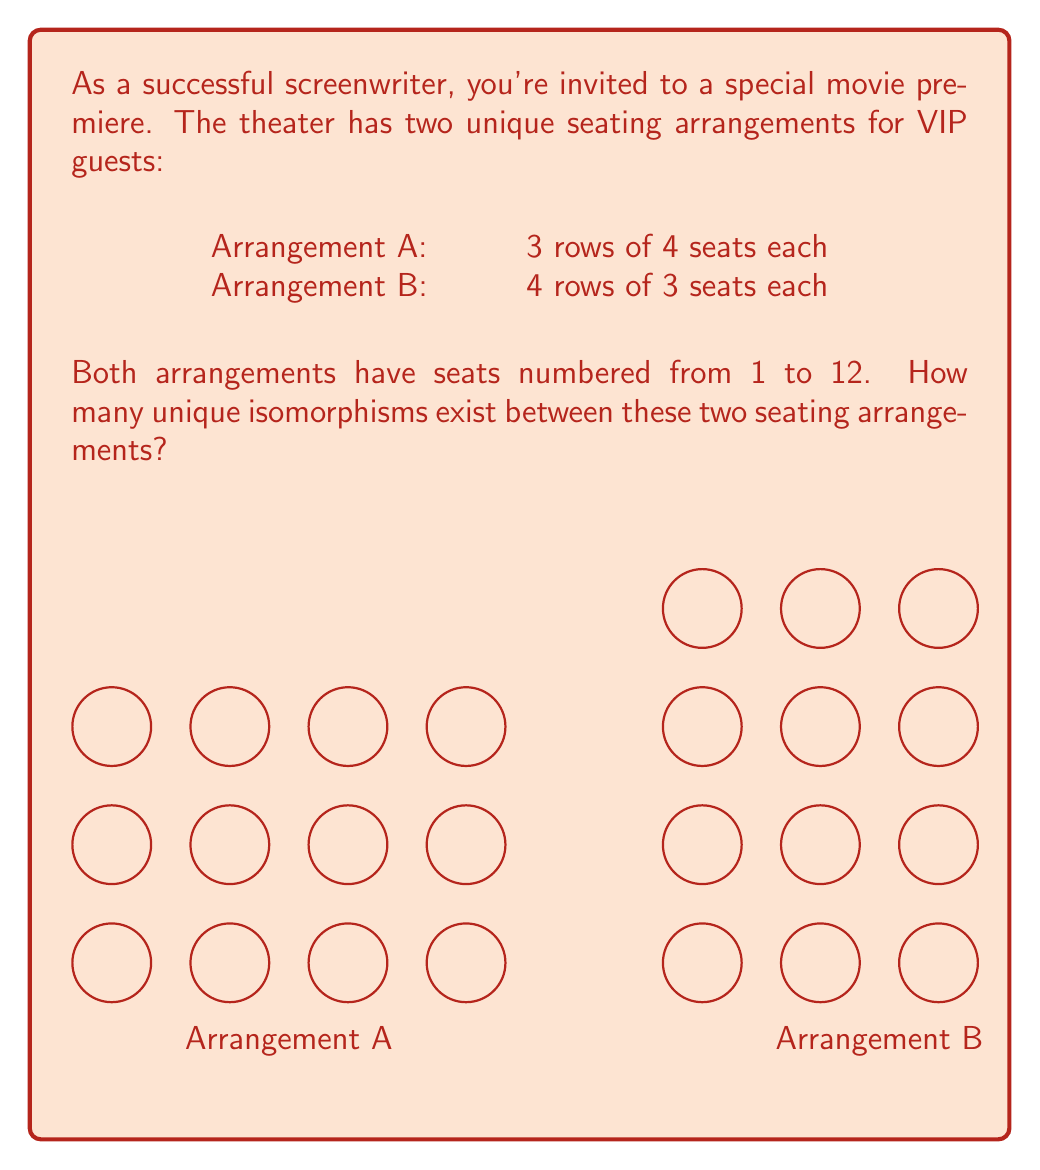What is the answer to this math problem? To solve this problem, we need to understand the concept of isomorphisms in group theory and apply it to our seating arrangements.

1) First, let's consider what an isomorphism means in this context:
   An isomorphism is a bijective function that preserves the structure of the seating arrangements.

2) In our case, the structure to preserve is the adjacency of seats. Two seats are adjacent if they are next to each other horizontally, vertically, or diagonally.

3) Now, let's count the number of unique ways to map Arrangement A to Arrangement B while preserving adjacency:

   a) We have 12 choices for the first seat in Arrangement B to map to seat 1 in Arrangement A.
   
   b) Once we've chosen the first seat, we have 3 choices for the seat that will correspond to seat 2 in Arrangement A (the seats adjacent to our first choice in Arrangement B).
   
   c) For the third seat, we have only 1 choice left that preserves adjacency.

   d) After these three choices, the rest of the mapping is forced to preserve adjacency.

4) Therefore, the total number of unique isomorphisms is:

   $$ 12 \times 3 \times 1 = 36 $$

5) We can verify this result by considering the symmetries of the arrangements:
   - Arrangement A has 2 symmetries (identity and vertical flip)
   - Arrangement B has 2 symmetries (identity and horizontal flip)
   - The total number of bijections between 12 elements is 12! (factorial of 12)
   - The number of isomorphisms is thus: $\frac{12!}{2 \times 2} = 36$

This confirms our initial calculation.
Answer: 36 isomorphisms 